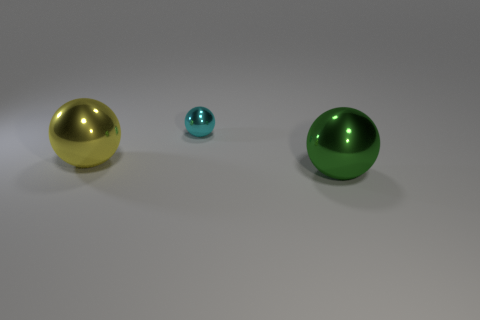How many big green things are to the right of the shiny sphere on the left side of the small ball?
Make the answer very short. 1. There is a green ball that is the same size as the yellow metallic ball; what material is it?
Offer a very short reply. Metal. There is a ball that is on the left side of the green metal ball and in front of the cyan object; what is its size?
Provide a succinct answer. Large. Is the material of the tiny ball the same as the big thing that is behind the green shiny thing?
Offer a terse response. Yes. What is the shape of the metal object that is both in front of the small cyan sphere and to the right of the yellow ball?
Provide a succinct answer. Sphere. There is another green sphere that is made of the same material as the tiny ball; what size is it?
Ensure brevity in your answer.  Large. Does the metal object right of the cyan ball have the same size as the small metallic sphere?
Your answer should be very brief. No. What color is the metal ball in front of the yellow sphere?
Offer a terse response. Green. What is the color of the other big shiny object that is the same shape as the large yellow shiny object?
Your answer should be very brief. Green. How many big balls are behind the large metallic sphere on the right side of the big yellow metallic ball in front of the tiny cyan sphere?
Your response must be concise. 1. 